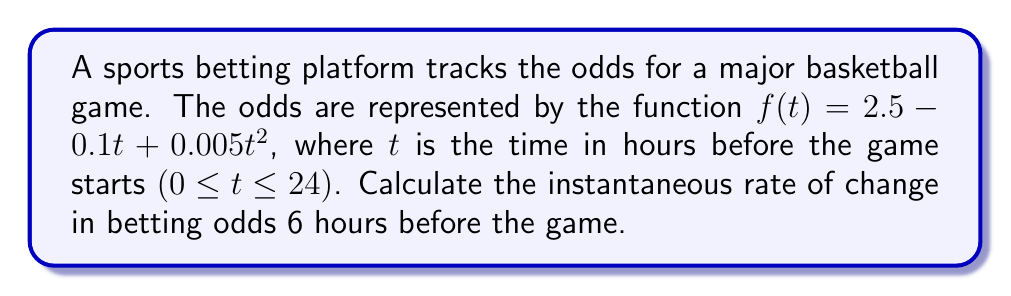Can you solve this math problem? To find the instantaneous rate of change, we need to calculate the derivative of the function $f(t)$ and evaluate it at $t = 6$.

Step 1: Find the derivative of $f(t)$.
$$f(t) = 2.5 - 0.1t + 0.005t^2$$
$$f'(t) = -0.1 + 0.01t$$

Step 2: Evaluate $f'(t)$ at $t = 6$.
$$f'(6) = -0.1 + 0.01(6)$$
$$f'(6) = -0.1 + 0.06$$
$$f'(6) = -0.04$$

The negative value indicates that the odds are decreasing at this point in time.
Answer: $-0.04$ per hour 